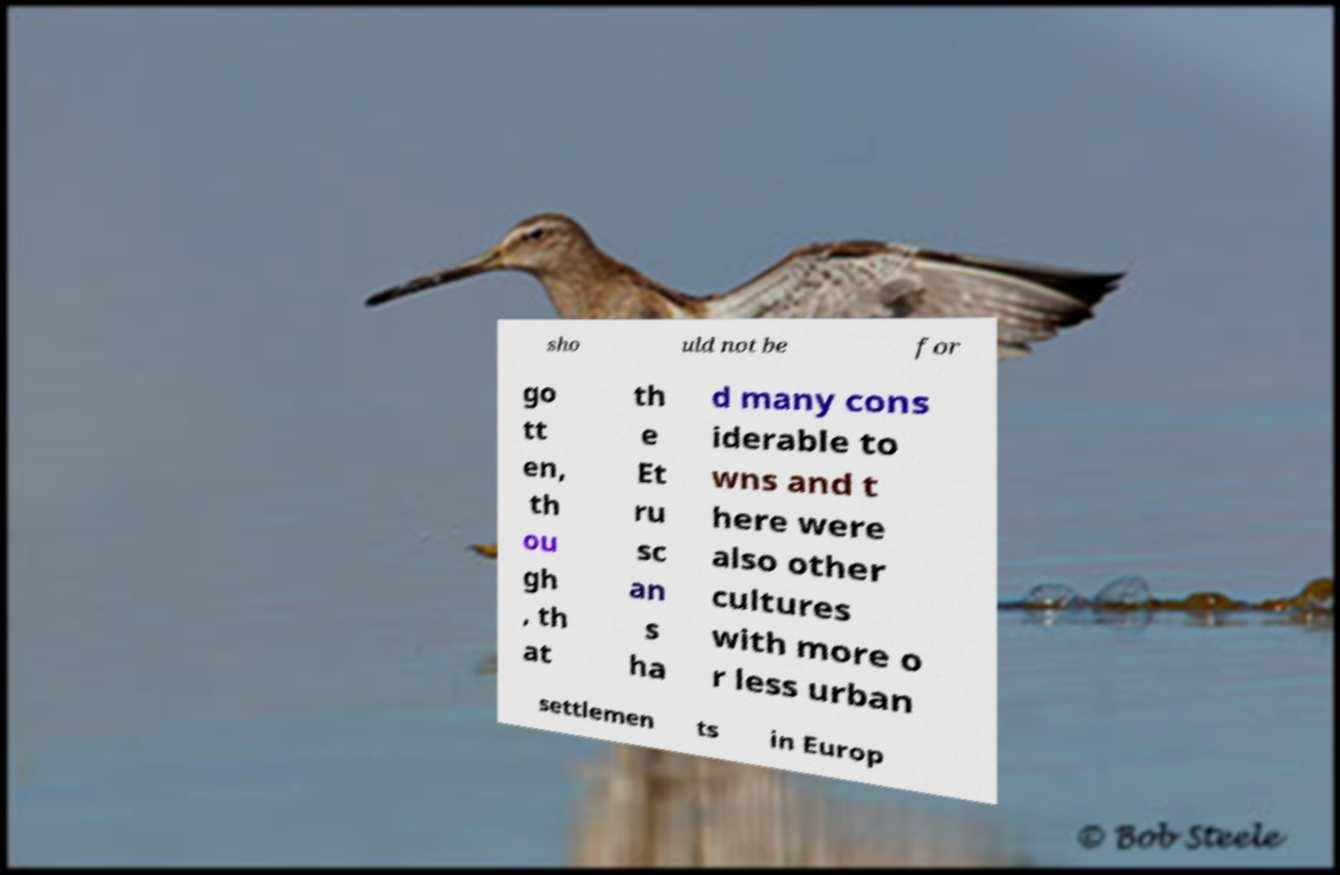Please identify and transcribe the text found in this image. sho uld not be for go tt en, th ou gh , th at th e Et ru sc an s ha d many cons iderable to wns and t here were also other cultures with more o r less urban settlemen ts in Europ 